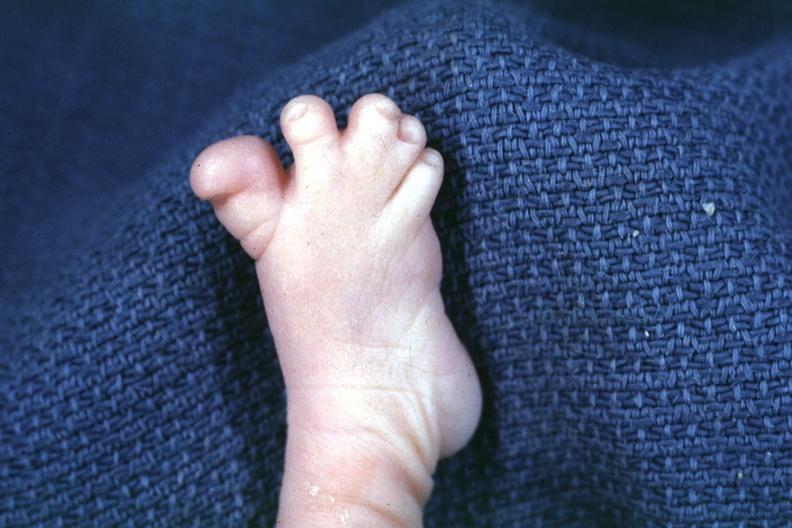does this image show nice photo of syndactyly?
Answer the question using a single word or phrase. Yes 